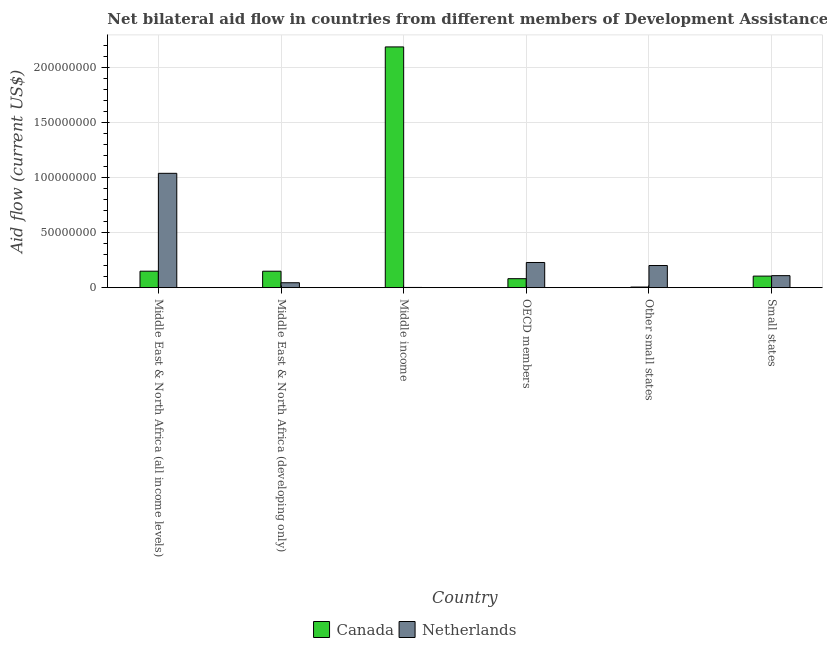How many groups of bars are there?
Keep it short and to the point. 6. Are the number of bars per tick equal to the number of legend labels?
Provide a succinct answer. Yes. Are the number of bars on each tick of the X-axis equal?
Offer a very short reply. Yes. How many bars are there on the 4th tick from the right?
Provide a succinct answer. 2. What is the label of the 2nd group of bars from the left?
Offer a very short reply. Middle East & North Africa (developing only). In how many cases, is the number of bars for a given country not equal to the number of legend labels?
Keep it short and to the point. 0. What is the amount of aid given by netherlands in OECD members?
Offer a terse response. 2.28e+07. Across all countries, what is the maximum amount of aid given by netherlands?
Offer a very short reply. 1.04e+08. Across all countries, what is the minimum amount of aid given by netherlands?
Ensure brevity in your answer.  2.00e+05. In which country was the amount of aid given by netherlands maximum?
Give a very brief answer. Middle East & North Africa (all income levels). In which country was the amount of aid given by canada minimum?
Offer a very short reply. Other small states. What is the total amount of aid given by netherlands in the graph?
Your answer should be compact. 1.62e+08. What is the difference between the amount of aid given by canada in Middle East & North Africa (all income levels) and that in OECD members?
Provide a short and direct response. 6.80e+06. What is the difference between the amount of aid given by netherlands in Middle income and the amount of aid given by canada in Middle East & North Africa (all income levels)?
Ensure brevity in your answer.  -1.48e+07. What is the average amount of aid given by canada per country?
Your response must be concise. 4.46e+07. What is the difference between the amount of aid given by netherlands and amount of aid given by canada in Middle East & North Africa (developing only)?
Provide a short and direct response. -1.05e+07. In how many countries, is the amount of aid given by canada greater than 20000000 US$?
Your response must be concise. 1. What is the ratio of the amount of aid given by netherlands in OECD members to that in Small states?
Your response must be concise. 2.09. Is the amount of aid given by canada in Middle East & North Africa (all income levels) less than that in Other small states?
Give a very brief answer. No. Is the difference between the amount of aid given by canada in Middle East & North Africa (developing only) and Other small states greater than the difference between the amount of aid given by netherlands in Middle East & North Africa (developing only) and Other small states?
Keep it short and to the point. Yes. What is the difference between the highest and the second highest amount of aid given by canada?
Offer a terse response. 2.04e+08. What is the difference between the highest and the lowest amount of aid given by canada?
Ensure brevity in your answer.  2.18e+08. Are all the bars in the graph horizontal?
Your response must be concise. No. What is the difference between two consecutive major ticks on the Y-axis?
Provide a succinct answer. 5.00e+07. Are the values on the major ticks of Y-axis written in scientific E-notation?
Give a very brief answer. No. Does the graph contain any zero values?
Offer a very short reply. No. Where does the legend appear in the graph?
Give a very brief answer. Bottom center. What is the title of the graph?
Your response must be concise. Net bilateral aid flow in countries from different members of Development Assistance Committee. Does "Under five" appear as one of the legend labels in the graph?
Your answer should be compact. No. What is the label or title of the Y-axis?
Provide a short and direct response. Aid flow (current US$). What is the Aid flow (current US$) in Canada in Middle East & North Africa (all income levels)?
Keep it short and to the point. 1.50e+07. What is the Aid flow (current US$) of Netherlands in Middle East & North Africa (all income levels)?
Make the answer very short. 1.04e+08. What is the Aid flow (current US$) of Canada in Middle East & North Africa (developing only)?
Give a very brief answer. 1.49e+07. What is the Aid flow (current US$) in Netherlands in Middle East & North Africa (developing only)?
Keep it short and to the point. 4.46e+06. What is the Aid flow (current US$) of Canada in Middle income?
Ensure brevity in your answer.  2.19e+08. What is the Aid flow (current US$) of Canada in OECD members?
Your response must be concise. 8.15e+06. What is the Aid flow (current US$) of Netherlands in OECD members?
Keep it short and to the point. 2.28e+07. What is the Aid flow (current US$) in Canada in Other small states?
Your response must be concise. 5.60e+05. What is the Aid flow (current US$) of Netherlands in Other small states?
Ensure brevity in your answer.  2.01e+07. What is the Aid flow (current US$) in Canada in Small states?
Your answer should be compact. 1.05e+07. What is the Aid flow (current US$) of Netherlands in Small states?
Ensure brevity in your answer.  1.09e+07. Across all countries, what is the maximum Aid flow (current US$) of Canada?
Provide a succinct answer. 2.19e+08. Across all countries, what is the maximum Aid flow (current US$) of Netherlands?
Offer a terse response. 1.04e+08. Across all countries, what is the minimum Aid flow (current US$) of Canada?
Make the answer very short. 5.60e+05. What is the total Aid flow (current US$) of Canada in the graph?
Your answer should be very brief. 2.68e+08. What is the total Aid flow (current US$) of Netherlands in the graph?
Provide a short and direct response. 1.62e+08. What is the difference between the Aid flow (current US$) in Canada in Middle East & North Africa (all income levels) and that in Middle East & North Africa (developing only)?
Your response must be concise. 10000. What is the difference between the Aid flow (current US$) of Netherlands in Middle East & North Africa (all income levels) and that in Middle East & North Africa (developing only)?
Give a very brief answer. 9.93e+07. What is the difference between the Aid flow (current US$) of Canada in Middle East & North Africa (all income levels) and that in Middle income?
Offer a terse response. -2.04e+08. What is the difference between the Aid flow (current US$) of Netherlands in Middle East & North Africa (all income levels) and that in Middle income?
Your response must be concise. 1.04e+08. What is the difference between the Aid flow (current US$) of Canada in Middle East & North Africa (all income levels) and that in OECD members?
Provide a short and direct response. 6.80e+06. What is the difference between the Aid flow (current US$) in Netherlands in Middle East & North Africa (all income levels) and that in OECD members?
Ensure brevity in your answer.  8.09e+07. What is the difference between the Aid flow (current US$) of Canada in Middle East & North Africa (all income levels) and that in Other small states?
Provide a succinct answer. 1.44e+07. What is the difference between the Aid flow (current US$) in Netherlands in Middle East & North Africa (all income levels) and that in Other small states?
Keep it short and to the point. 8.37e+07. What is the difference between the Aid flow (current US$) in Canada in Middle East & North Africa (all income levels) and that in Small states?
Provide a short and direct response. 4.46e+06. What is the difference between the Aid flow (current US$) of Netherlands in Middle East & North Africa (all income levels) and that in Small states?
Offer a very short reply. 9.29e+07. What is the difference between the Aid flow (current US$) in Canada in Middle East & North Africa (developing only) and that in Middle income?
Offer a terse response. -2.04e+08. What is the difference between the Aid flow (current US$) of Netherlands in Middle East & North Africa (developing only) and that in Middle income?
Your answer should be very brief. 4.26e+06. What is the difference between the Aid flow (current US$) of Canada in Middle East & North Africa (developing only) and that in OECD members?
Provide a succinct answer. 6.79e+06. What is the difference between the Aid flow (current US$) of Netherlands in Middle East & North Africa (developing only) and that in OECD members?
Offer a terse response. -1.84e+07. What is the difference between the Aid flow (current US$) of Canada in Middle East & North Africa (developing only) and that in Other small states?
Provide a succinct answer. 1.44e+07. What is the difference between the Aid flow (current US$) in Netherlands in Middle East & North Africa (developing only) and that in Other small states?
Offer a terse response. -1.56e+07. What is the difference between the Aid flow (current US$) in Canada in Middle East & North Africa (developing only) and that in Small states?
Ensure brevity in your answer.  4.45e+06. What is the difference between the Aid flow (current US$) of Netherlands in Middle East & North Africa (developing only) and that in Small states?
Your response must be concise. -6.45e+06. What is the difference between the Aid flow (current US$) in Canada in Middle income and that in OECD members?
Keep it short and to the point. 2.10e+08. What is the difference between the Aid flow (current US$) of Netherlands in Middle income and that in OECD members?
Ensure brevity in your answer.  -2.26e+07. What is the difference between the Aid flow (current US$) in Canada in Middle income and that in Other small states?
Your answer should be very brief. 2.18e+08. What is the difference between the Aid flow (current US$) in Netherlands in Middle income and that in Other small states?
Keep it short and to the point. -1.99e+07. What is the difference between the Aid flow (current US$) in Canada in Middle income and that in Small states?
Make the answer very short. 2.08e+08. What is the difference between the Aid flow (current US$) in Netherlands in Middle income and that in Small states?
Keep it short and to the point. -1.07e+07. What is the difference between the Aid flow (current US$) of Canada in OECD members and that in Other small states?
Your answer should be compact. 7.59e+06. What is the difference between the Aid flow (current US$) in Netherlands in OECD members and that in Other small states?
Make the answer very short. 2.75e+06. What is the difference between the Aid flow (current US$) of Canada in OECD members and that in Small states?
Your answer should be compact. -2.34e+06. What is the difference between the Aid flow (current US$) of Netherlands in OECD members and that in Small states?
Provide a succinct answer. 1.19e+07. What is the difference between the Aid flow (current US$) of Canada in Other small states and that in Small states?
Make the answer very short. -9.93e+06. What is the difference between the Aid flow (current US$) of Netherlands in Other small states and that in Small states?
Your answer should be very brief. 9.19e+06. What is the difference between the Aid flow (current US$) in Canada in Middle East & North Africa (all income levels) and the Aid flow (current US$) in Netherlands in Middle East & North Africa (developing only)?
Keep it short and to the point. 1.05e+07. What is the difference between the Aid flow (current US$) of Canada in Middle East & North Africa (all income levels) and the Aid flow (current US$) of Netherlands in Middle income?
Your answer should be very brief. 1.48e+07. What is the difference between the Aid flow (current US$) in Canada in Middle East & North Africa (all income levels) and the Aid flow (current US$) in Netherlands in OECD members?
Ensure brevity in your answer.  -7.90e+06. What is the difference between the Aid flow (current US$) in Canada in Middle East & North Africa (all income levels) and the Aid flow (current US$) in Netherlands in Other small states?
Offer a terse response. -5.15e+06. What is the difference between the Aid flow (current US$) in Canada in Middle East & North Africa (all income levels) and the Aid flow (current US$) in Netherlands in Small states?
Ensure brevity in your answer.  4.04e+06. What is the difference between the Aid flow (current US$) in Canada in Middle East & North Africa (developing only) and the Aid flow (current US$) in Netherlands in Middle income?
Give a very brief answer. 1.47e+07. What is the difference between the Aid flow (current US$) in Canada in Middle East & North Africa (developing only) and the Aid flow (current US$) in Netherlands in OECD members?
Ensure brevity in your answer.  -7.91e+06. What is the difference between the Aid flow (current US$) of Canada in Middle East & North Africa (developing only) and the Aid flow (current US$) of Netherlands in Other small states?
Your answer should be compact. -5.16e+06. What is the difference between the Aid flow (current US$) of Canada in Middle East & North Africa (developing only) and the Aid flow (current US$) of Netherlands in Small states?
Your answer should be very brief. 4.03e+06. What is the difference between the Aid flow (current US$) in Canada in Middle income and the Aid flow (current US$) in Netherlands in OECD members?
Keep it short and to the point. 1.96e+08. What is the difference between the Aid flow (current US$) in Canada in Middle income and the Aid flow (current US$) in Netherlands in Other small states?
Give a very brief answer. 1.98e+08. What is the difference between the Aid flow (current US$) of Canada in Middle income and the Aid flow (current US$) of Netherlands in Small states?
Give a very brief answer. 2.08e+08. What is the difference between the Aid flow (current US$) of Canada in OECD members and the Aid flow (current US$) of Netherlands in Other small states?
Your answer should be compact. -1.20e+07. What is the difference between the Aid flow (current US$) of Canada in OECD members and the Aid flow (current US$) of Netherlands in Small states?
Make the answer very short. -2.76e+06. What is the difference between the Aid flow (current US$) of Canada in Other small states and the Aid flow (current US$) of Netherlands in Small states?
Offer a terse response. -1.04e+07. What is the average Aid flow (current US$) in Canada per country?
Your answer should be compact. 4.46e+07. What is the average Aid flow (current US$) in Netherlands per country?
Give a very brief answer. 2.71e+07. What is the difference between the Aid flow (current US$) of Canada and Aid flow (current US$) of Netherlands in Middle East & North Africa (all income levels)?
Ensure brevity in your answer.  -8.88e+07. What is the difference between the Aid flow (current US$) of Canada and Aid flow (current US$) of Netherlands in Middle East & North Africa (developing only)?
Provide a short and direct response. 1.05e+07. What is the difference between the Aid flow (current US$) of Canada and Aid flow (current US$) of Netherlands in Middle income?
Offer a very short reply. 2.18e+08. What is the difference between the Aid flow (current US$) in Canada and Aid flow (current US$) in Netherlands in OECD members?
Offer a terse response. -1.47e+07. What is the difference between the Aid flow (current US$) in Canada and Aid flow (current US$) in Netherlands in Other small states?
Give a very brief answer. -1.95e+07. What is the difference between the Aid flow (current US$) in Canada and Aid flow (current US$) in Netherlands in Small states?
Your answer should be compact. -4.20e+05. What is the ratio of the Aid flow (current US$) in Netherlands in Middle East & North Africa (all income levels) to that in Middle East & North Africa (developing only)?
Offer a terse response. 23.27. What is the ratio of the Aid flow (current US$) in Canada in Middle East & North Africa (all income levels) to that in Middle income?
Make the answer very short. 0.07. What is the ratio of the Aid flow (current US$) of Netherlands in Middle East & North Africa (all income levels) to that in Middle income?
Give a very brief answer. 518.95. What is the ratio of the Aid flow (current US$) of Canada in Middle East & North Africa (all income levels) to that in OECD members?
Your answer should be compact. 1.83. What is the ratio of the Aid flow (current US$) of Netherlands in Middle East & North Africa (all income levels) to that in OECD members?
Provide a short and direct response. 4.54. What is the ratio of the Aid flow (current US$) of Canada in Middle East & North Africa (all income levels) to that in Other small states?
Keep it short and to the point. 26.7. What is the ratio of the Aid flow (current US$) in Netherlands in Middle East & North Africa (all income levels) to that in Other small states?
Give a very brief answer. 5.16. What is the ratio of the Aid flow (current US$) in Canada in Middle East & North Africa (all income levels) to that in Small states?
Ensure brevity in your answer.  1.43. What is the ratio of the Aid flow (current US$) in Netherlands in Middle East & North Africa (all income levels) to that in Small states?
Offer a terse response. 9.51. What is the ratio of the Aid flow (current US$) in Canada in Middle East & North Africa (developing only) to that in Middle income?
Ensure brevity in your answer.  0.07. What is the ratio of the Aid flow (current US$) in Netherlands in Middle East & North Africa (developing only) to that in Middle income?
Your answer should be very brief. 22.3. What is the ratio of the Aid flow (current US$) of Canada in Middle East & North Africa (developing only) to that in OECD members?
Your answer should be compact. 1.83. What is the ratio of the Aid flow (current US$) in Netherlands in Middle East & North Africa (developing only) to that in OECD members?
Provide a succinct answer. 0.2. What is the ratio of the Aid flow (current US$) of Canada in Middle East & North Africa (developing only) to that in Other small states?
Offer a very short reply. 26.68. What is the ratio of the Aid flow (current US$) of Netherlands in Middle East & North Africa (developing only) to that in Other small states?
Give a very brief answer. 0.22. What is the ratio of the Aid flow (current US$) of Canada in Middle East & North Africa (developing only) to that in Small states?
Your response must be concise. 1.42. What is the ratio of the Aid flow (current US$) of Netherlands in Middle East & North Africa (developing only) to that in Small states?
Your answer should be very brief. 0.41. What is the ratio of the Aid flow (current US$) of Canada in Middle income to that in OECD members?
Give a very brief answer. 26.81. What is the ratio of the Aid flow (current US$) in Netherlands in Middle income to that in OECD members?
Your response must be concise. 0.01. What is the ratio of the Aid flow (current US$) in Canada in Middle income to that in Other small states?
Provide a succinct answer. 390.23. What is the ratio of the Aid flow (current US$) of Netherlands in Middle income to that in Other small states?
Your answer should be compact. 0.01. What is the ratio of the Aid flow (current US$) of Canada in Middle income to that in Small states?
Your answer should be compact. 20.83. What is the ratio of the Aid flow (current US$) in Netherlands in Middle income to that in Small states?
Offer a terse response. 0.02. What is the ratio of the Aid flow (current US$) in Canada in OECD members to that in Other small states?
Offer a very short reply. 14.55. What is the ratio of the Aid flow (current US$) of Netherlands in OECD members to that in Other small states?
Offer a terse response. 1.14. What is the ratio of the Aid flow (current US$) in Canada in OECD members to that in Small states?
Keep it short and to the point. 0.78. What is the ratio of the Aid flow (current US$) in Netherlands in OECD members to that in Small states?
Your answer should be very brief. 2.09. What is the ratio of the Aid flow (current US$) of Canada in Other small states to that in Small states?
Offer a very short reply. 0.05. What is the ratio of the Aid flow (current US$) in Netherlands in Other small states to that in Small states?
Your response must be concise. 1.84. What is the difference between the highest and the second highest Aid flow (current US$) of Canada?
Your response must be concise. 2.04e+08. What is the difference between the highest and the second highest Aid flow (current US$) of Netherlands?
Keep it short and to the point. 8.09e+07. What is the difference between the highest and the lowest Aid flow (current US$) in Canada?
Give a very brief answer. 2.18e+08. What is the difference between the highest and the lowest Aid flow (current US$) of Netherlands?
Make the answer very short. 1.04e+08. 